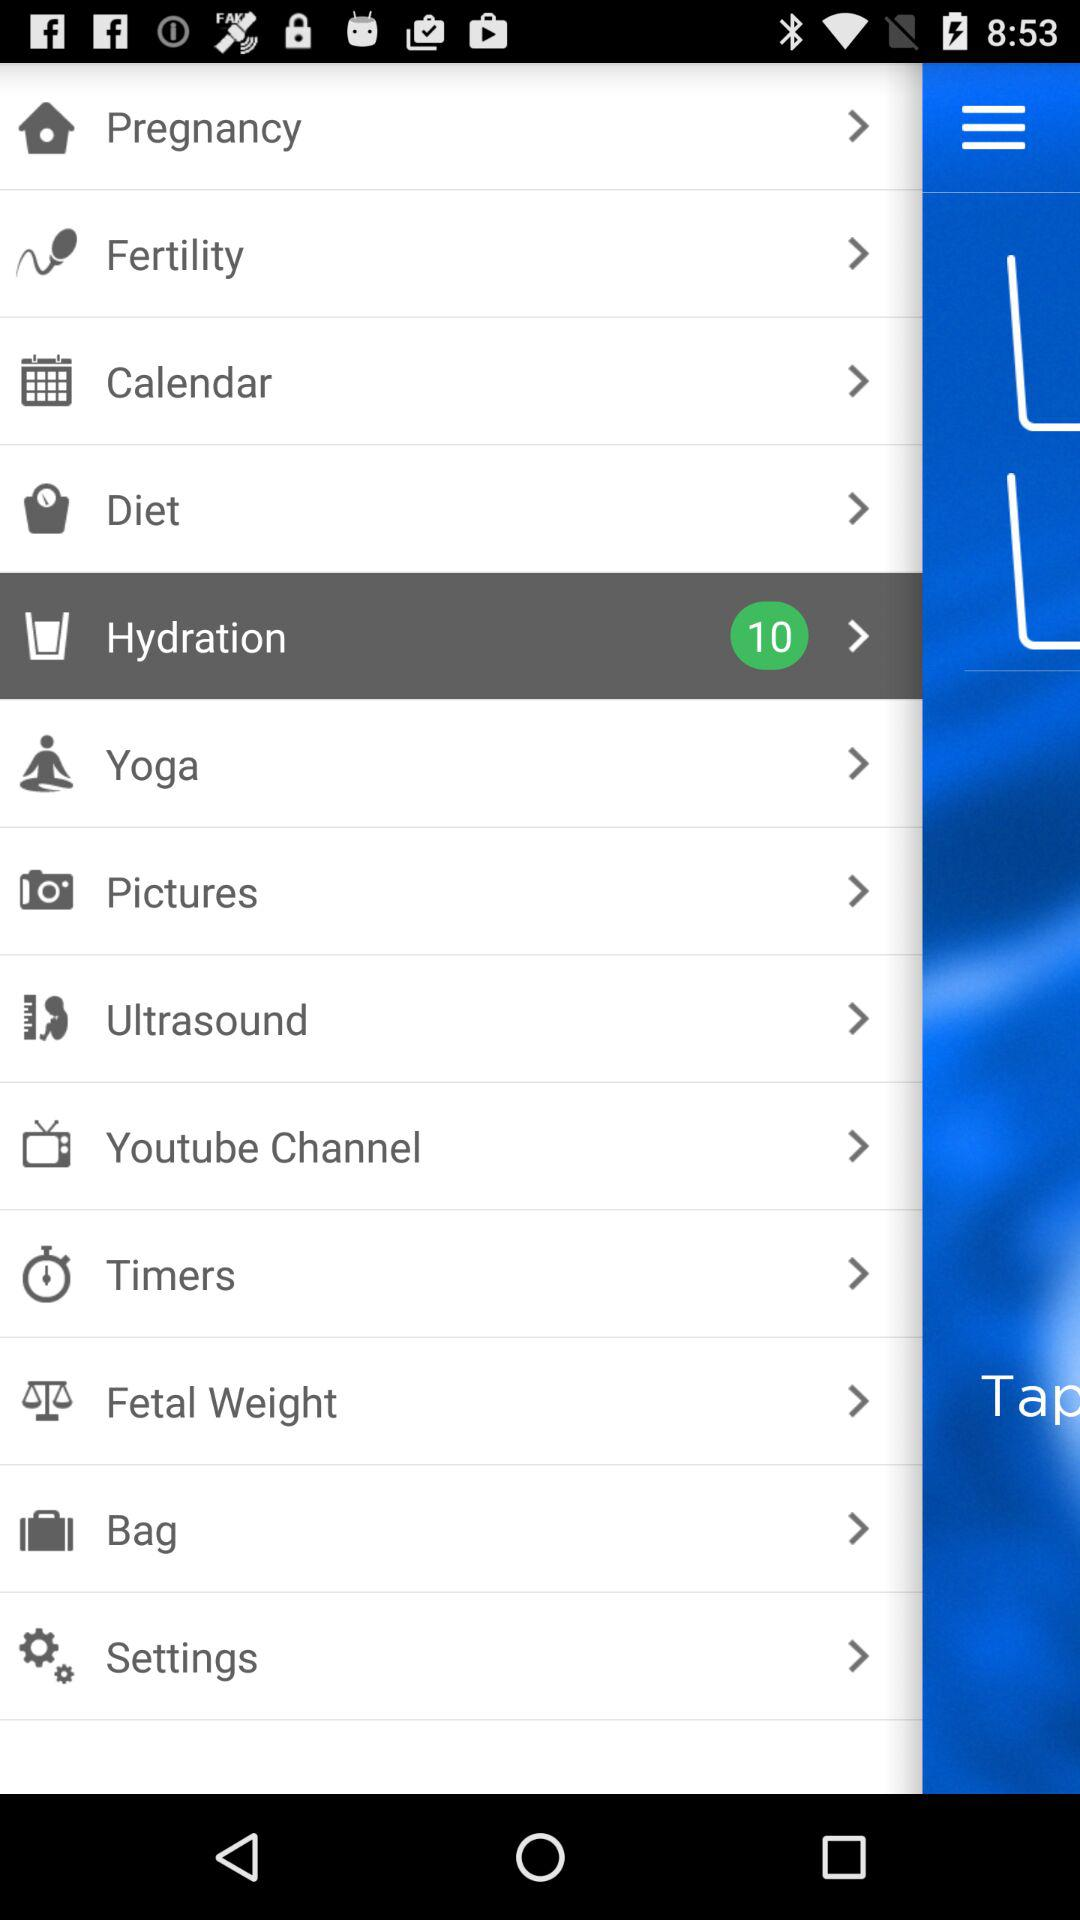What is the count of items shown in "Hydration"? The count of items shown in "Hydration" is 10. 